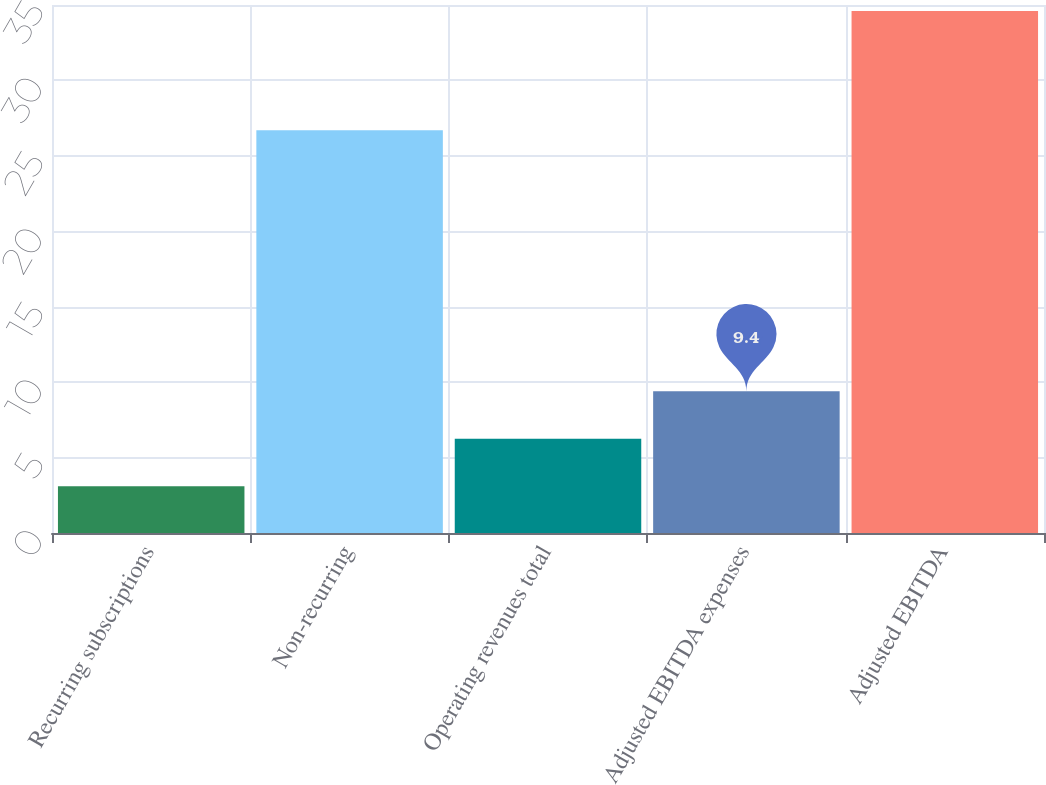Convert chart to OTSL. <chart><loc_0><loc_0><loc_500><loc_500><bar_chart><fcel>Recurring subscriptions<fcel>Non-recurring<fcel>Operating revenues total<fcel>Adjusted EBITDA expenses<fcel>Adjusted EBITDA<nl><fcel>3.1<fcel>26.7<fcel>6.25<fcel>9.4<fcel>34.6<nl></chart> 